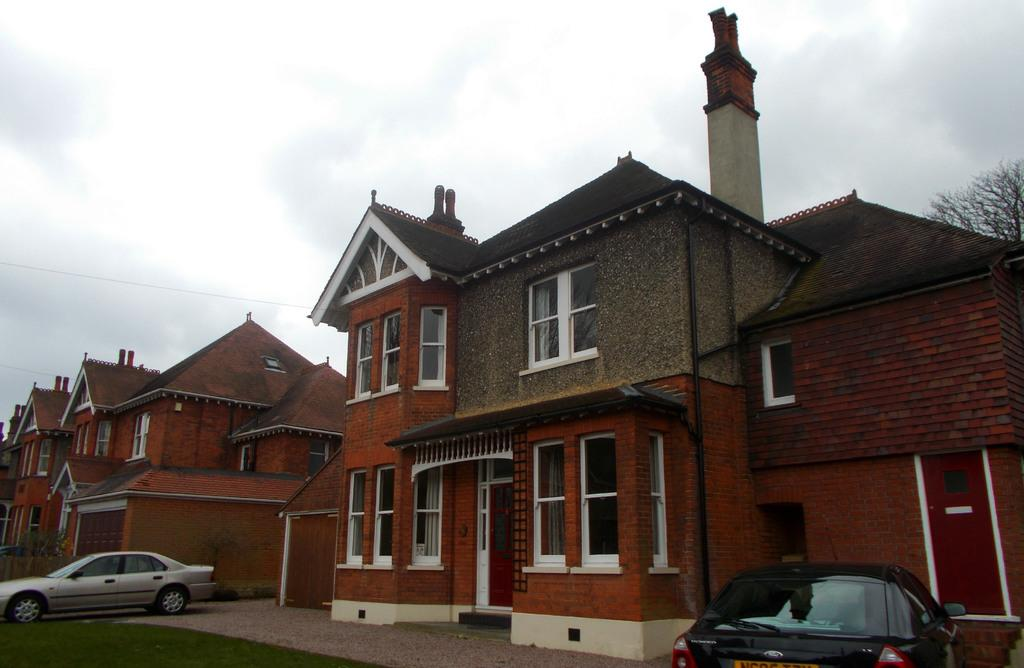What type of vegetation is present on the ground in the front of the image? There is grass on the ground in the front of the image. What can be seen in the background of the image? There are cars and houses in the background of the image. What is the condition of the tree on the right side of the image? The tree on the right side of the image is dry. What is the weather like in the image? The sky is cloudy in the image. What is the price of the floor in the image? There is no mention of a floor in the image, and therefore no price can be determined. What type of town is depicted in the image? The image does not depict a town; it shows grass, a dry tree, cars, houses, and a cloudy sky. 